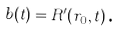Convert formula to latex. <formula><loc_0><loc_0><loc_500><loc_500>b ( t ) = R ^ { \prime } ( r _ { 0 } , t ) \text {.}</formula> 